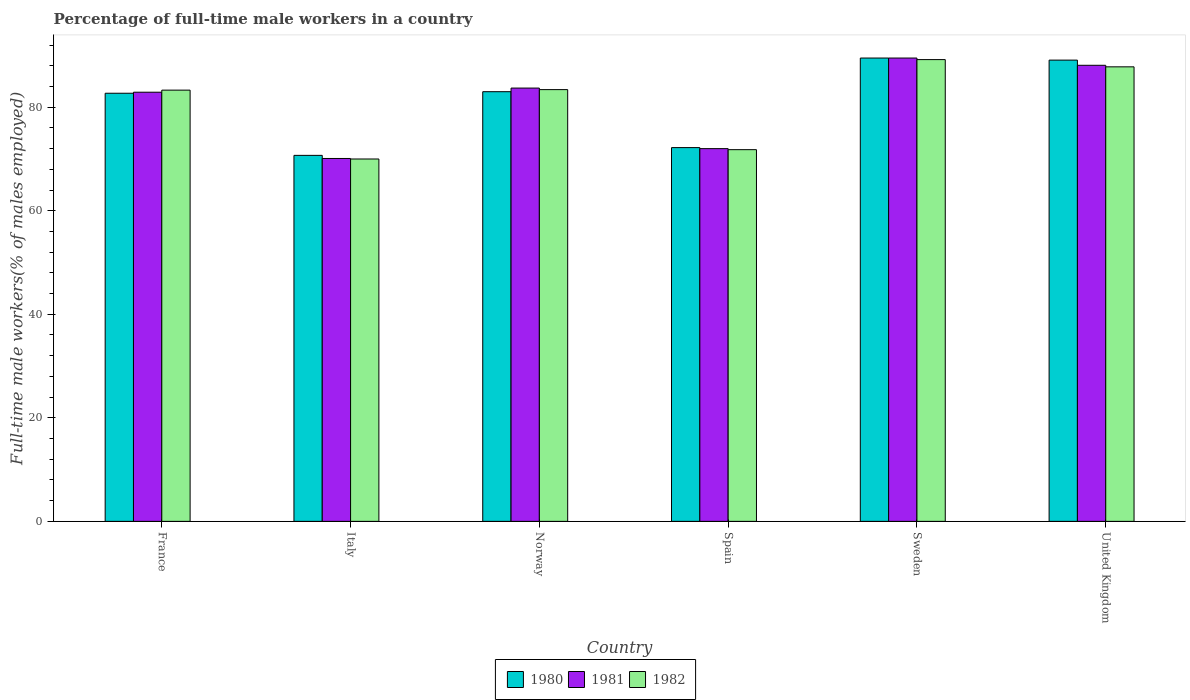How many groups of bars are there?
Ensure brevity in your answer.  6. Are the number of bars on each tick of the X-axis equal?
Offer a very short reply. Yes. How many bars are there on the 5th tick from the left?
Offer a terse response. 3. What is the label of the 2nd group of bars from the left?
Ensure brevity in your answer.  Italy. In how many cases, is the number of bars for a given country not equal to the number of legend labels?
Ensure brevity in your answer.  0. What is the percentage of full-time male workers in 1982 in France?
Offer a very short reply. 83.3. Across all countries, what is the maximum percentage of full-time male workers in 1981?
Ensure brevity in your answer.  89.5. In which country was the percentage of full-time male workers in 1981 minimum?
Your answer should be compact. Italy. What is the total percentage of full-time male workers in 1981 in the graph?
Provide a succinct answer. 486.3. What is the difference between the percentage of full-time male workers in 1982 in Spain and that in Sweden?
Provide a succinct answer. -17.4. What is the difference between the percentage of full-time male workers in 1980 in Spain and the percentage of full-time male workers in 1981 in United Kingdom?
Your response must be concise. -15.9. What is the average percentage of full-time male workers in 1980 per country?
Offer a terse response. 81.2. What is the difference between the percentage of full-time male workers of/in 1981 and percentage of full-time male workers of/in 1982 in Italy?
Offer a very short reply. 0.1. In how many countries, is the percentage of full-time male workers in 1981 greater than 68 %?
Make the answer very short. 6. What is the ratio of the percentage of full-time male workers in 1980 in Italy to that in Norway?
Provide a succinct answer. 0.85. Is the percentage of full-time male workers in 1982 in Italy less than that in Norway?
Keep it short and to the point. Yes. What is the difference between the highest and the second highest percentage of full-time male workers in 1982?
Your response must be concise. 5.8. What is the difference between the highest and the lowest percentage of full-time male workers in 1981?
Provide a succinct answer. 19.4. In how many countries, is the percentage of full-time male workers in 1980 greater than the average percentage of full-time male workers in 1980 taken over all countries?
Offer a very short reply. 4. What does the 3rd bar from the left in France represents?
Your answer should be compact. 1982. Is it the case that in every country, the sum of the percentage of full-time male workers in 1981 and percentage of full-time male workers in 1982 is greater than the percentage of full-time male workers in 1980?
Keep it short and to the point. Yes. Are all the bars in the graph horizontal?
Make the answer very short. No. What is the difference between two consecutive major ticks on the Y-axis?
Provide a short and direct response. 20. Does the graph contain any zero values?
Offer a terse response. No. Does the graph contain grids?
Keep it short and to the point. No. How many legend labels are there?
Your answer should be compact. 3. What is the title of the graph?
Offer a very short reply. Percentage of full-time male workers in a country. What is the label or title of the X-axis?
Ensure brevity in your answer.  Country. What is the label or title of the Y-axis?
Keep it short and to the point. Full-time male workers(% of males employed). What is the Full-time male workers(% of males employed) of 1980 in France?
Give a very brief answer. 82.7. What is the Full-time male workers(% of males employed) of 1981 in France?
Offer a terse response. 82.9. What is the Full-time male workers(% of males employed) of 1982 in France?
Your answer should be very brief. 83.3. What is the Full-time male workers(% of males employed) of 1980 in Italy?
Give a very brief answer. 70.7. What is the Full-time male workers(% of males employed) in 1981 in Italy?
Your answer should be compact. 70.1. What is the Full-time male workers(% of males employed) of 1980 in Norway?
Give a very brief answer. 83. What is the Full-time male workers(% of males employed) in 1981 in Norway?
Your response must be concise. 83.7. What is the Full-time male workers(% of males employed) of 1982 in Norway?
Provide a short and direct response. 83.4. What is the Full-time male workers(% of males employed) of 1980 in Spain?
Offer a terse response. 72.2. What is the Full-time male workers(% of males employed) in 1982 in Spain?
Offer a terse response. 71.8. What is the Full-time male workers(% of males employed) in 1980 in Sweden?
Your answer should be very brief. 89.5. What is the Full-time male workers(% of males employed) of 1981 in Sweden?
Your answer should be compact. 89.5. What is the Full-time male workers(% of males employed) of 1982 in Sweden?
Ensure brevity in your answer.  89.2. What is the Full-time male workers(% of males employed) of 1980 in United Kingdom?
Keep it short and to the point. 89.1. What is the Full-time male workers(% of males employed) in 1981 in United Kingdom?
Ensure brevity in your answer.  88.1. What is the Full-time male workers(% of males employed) of 1982 in United Kingdom?
Provide a short and direct response. 87.8. Across all countries, what is the maximum Full-time male workers(% of males employed) in 1980?
Give a very brief answer. 89.5. Across all countries, what is the maximum Full-time male workers(% of males employed) in 1981?
Give a very brief answer. 89.5. Across all countries, what is the maximum Full-time male workers(% of males employed) of 1982?
Your response must be concise. 89.2. Across all countries, what is the minimum Full-time male workers(% of males employed) of 1980?
Provide a short and direct response. 70.7. Across all countries, what is the minimum Full-time male workers(% of males employed) of 1981?
Your answer should be compact. 70.1. What is the total Full-time male workers(% of males employed) of 1980 in the graph?
Offer a terse response. 487.2. What is the total Full-time male workers(% of males employed) of 1981 in the graph?
Provide a succinct answer. 486.3. What is the total Full-time male workers(% of males employed) in 1982 in the graph?
Give a very brief answer. 485.5. What is the difference between the Full-time male workers(% of males employed) in 1980 in France and that in Italy?
Give a very brief answer. 12. What is the difference between the Full-time male workers(% of males employed) of 1980 in France and that in Norway?
Your response must be concise. -0.3. What is the difference between the Full-time male workers(% of males employed) of 1981 in France and that in Spain?
Your answer should be compact. 10.9. What is the difference between the Full-time male workers(% of males employed) in 1982 in France and that in Spain?
Your answer should be very brief. 11.5. What is the difference between the Full-time male workers(% of males employed) in 1980 in France and that in Sweden?
Your answer should be very brief. -6.8. What is the difference between the Full-time male workers(% of males employed) in 1982 in France and that in United Kingdom?
Your response must be concise. -4.5. What is the difference between the Full-time male workers(% of males employed) in 1980 in Italy and that in Spain?
Your answer should be compact. -1.5. What is the difference between the Full-time male workers(% of males employed) of 1982 in Italy and that in Spain?
Offer a terse response. -1.8. What is the difference between the Full-time male workers(% of males employed) in 1980 in Italy and that in Sweden?
Provide a succinct answer. -18.8. What is the difference between the Full-time male workers(% of males employed) of 1981 in Italy and that in Sweden?
Offer a terse response. -19.4. What is the difference between the Full-time male workers(% of males employed) in 1982 in Italy and that in Sweden?
Your response must be concise. -19.2. What is the difference between the Full-time male workers(% of males employed) in 1980 in Italy and that in United Kingdom?
Provide a short and direct response. -18.4. What is the difference between the Full-time male workers(% of males employed) in 1981 in Italy and that in United Kingdom?
Provide a short and direct response. -18. What is the difference between the Full-time male workers(% of males employed) of 1982 in Italy and that in United Kingdom?
Offer a terse response. -17.8. What is the difference between the Full-time male workers(% of males employed) of 1980 in Norway and that in Spain?
Offer a very short reply. 10.8. What is the difference between the Full-time male workers(% of males employed) in 1981 in Norway and that in Spain?
Provide a succinct answer. 11.7. What is the difference between the Full-time male workers(% of males employed) of 1982 in Norway and that in Spain?
Your answer should be very brief. 11.6. What is the difference between the Full-time male workers(% of males employed) of 1981 in Norway and that in Sweden?
Your answer should be very brief. -5.8. What is the difference between the Full-time male workers(% of males employed) in 1982 in Norway and that in Sweden?
Your response must be concise. -5.8. What is the difference between the Full-time male workers(% of males employed) in 1980 in Norway and that in United Kingdom?
Provide a succinct answer. -6.1. What is the difference between the Full-time male workers(% of males employed) in 1981 in Norway and that in United Kingdom?
Offer a very short reply. -4.4. What is the difference between the Full-time male workers(% of males employed) of 1982 in Norway and that in United Kingdom?
Your answer should be very brief. -4.4. What is the difference between the Full-time male workers(% of males employed) of 1980 in Spain and that in Sweden?
Provide a short and direct response. -17.3. What is the difference between the Full-time male workers(% of males employed) of 1981 in Spain and that in Sweden?
Make the answer very short. -17.5. What is the difference between the Full-time male workers(% of males employed) of 1982 in Spain and that in Sweden?
Offer a terse response. -17.4. What is the difference between the Full-time male workers(% of males employed) in 1980 in Spain and that in United Kingdom?
Ensure brevity in your answer.  -16.9. What is the difference between the Full-time male workers(% of males employed) in 1981 in Spain and that in United Kingdom?
Make the answer very short. -16.1. What is the difference between the Full-time male workers(% of males employed) of 1982 in Sweden and that in United Kingdom?
Provide a succinct answer. 1.4. What is the difference between the Full-time male workers(% of males employed) of 1980 in France and the Full-time male workers(% of males employed) of 1981 in Italy?
Your answer should be very brief. 12.6. What is the difference between the Full-time male workers(% of males employed) in 1981 in France and the Full-time male workers(% of males employed) in 1982 in Italy?
Keep it short and to the point. 12.9. What is the difference between the Full-time male workers(% of males employed) of 1980 in France and the Full-time male workers(% of males employed) of 1981 in Spain?
Your response must be concise. 10.7. What is the difference between the Full-time male workers(% of males employed) in 1981 in France and the Full-time male workers(% of males employed) in 1982 in Spain?
Your response must be concise. 11.1. What is the difference between the Full-time male workers(% of males employed) in 1980 in France and the Full-time male workers(% of males employed) in 1981 in Sweden?
Offer a very short reply. -6.8. What is the difference between the Full-time male workers(% of males employed) in 1980 in France and the Full-time male workers(% of males employed) in 1982 in Sweden?
Your response must be concise. -6.5. What is the difference between the Full-time male workers(% of males employed) of 1981 in France and the Full-time male workers(% of males employed) of 1982 in Sweden?
Make the answer very short. -6.3. What is the difference between the Full-time male workers(% of males employed) in 1980 in France and the Full-time male workers(% of males employed) in 1982 in United Kingdom?
Your response must be concise. -5.1. What is the difference between the Full-time male workers(% of males employed) of 1981 in France and the Full-time male workers(% of males employed) of 1982 in United Kingdom?
Your response must be concise. -4.9. What is the difference between the Full-time male workers(% of males employed) of 1980 in Italy and the Full-time male workers(% of males employed) of 1981 in Norway?
Provide a short and direct response. -13. What is the difference between the Full-time male workers(% of males employed) of 1980 in Italy and the Full-time male workers(% of males employed) of 1982 in Norway?
Your response must be concise. -12.7. What is the difference between the Full-time male workers(% of males employed) in 1981 in Italy and the Full-time male workers(% of males employed) in 1982 in Norway?
Make the answer very short. -13.3. What is the difference between the Full-time male workers(% of males employed) of 1980 in Italy and the Full-time male workers(% of males employed) of 1981 in Spain?
Keep it short and to the point. -1.3. What is the difference between the Full-time male workers(% of males employed) in 1980 in Italy and the Full-time male workers(% of males employed) in 1982 in Spain?
Offer a terse response. -1.1. What is the difference between the Full-time male workers(% of males employed) in 1980 in Italy and the Full-time male workers(% of males employed) in 1981 in Sweden?
Provide a succinct answer. -18.8. What is the difference between the Full-time male workers(% of males employed) of 1980 in Italy and the Full-time male workers(% of males employed) of 1982 in Sweden?
Your response must be concise. -18.5. What is the difference between the Full-time male workers(% of males employed) of 1981 in Italy and the Full-time male workers(% of males employed) of 1982 in Sweden?
Keep it short and to the point. -19.1. What is the difference between the Full-time male workers(% of males employed) of 1980 in Italy and the Full-time male workers(% of males employed) of 1981 in United Kingdom?
Provide a succinct answer. -17.4. What is the difference between the Full-time male workers(% of males employed) of 1980 in Italy and the Full-time male workers(% of males employed) of 1982 in United Kingdom?
Give a very brief answer. -17.1. What is the difference between the Full-time male workers(% of males employed) in 1981 in Italy and the Full-time male workers(% of males employed) in 1982 in United Kingdom?
Ensure brevity in your answer.  -17.7. What is the difference between the Full-time male workers(% of males employed) in 1980 in Norway and the Full-time male workers(% of males employed) in 1982 in Spain?
Give a very brief answer. 11.2. What is the difference between the Full-time male workers(% of males employed) of 1981 in Norway and the Full-time male workers(% of males employed) of 1982 in Spain?
Give a very brief answer. 11.9. What is the difference between the Full-time male workers(% of males employed) in 1980 in Norway and the Full-time male workers(% of males employed) in 1982 in Sweden?
Ensure brevity in your answer.  -6.2. What is the difference between the Full-time male workers(% of males employed) in 1980 in Norway and the Full-time male workers(% of males employed) in 1982 in United Kingdom?
Provide a succinct answer. -4.8. What is the difference between the Full-time male workers(% of males employed) in 1980 in Spain and the Full-time male workers(% of males employed) in 1981 in Sweden?
Give a very brief answer. -17.3. What is the difference between the Full-time male workers(% of males employed) of 1980 in Spain and the Full-time male workers(% of males employed) of 1982 in Sweden?
Provide a short and direct response. -17. What is the difference between the Full-time male workers(% of males employed) in 1981 in Spain and the Full-time male workers(% of males employed) in 1982 in Sweden?
Your answer should be compact. -17.2. What is the difference between the Full-time male workers(% of males employed) of 1980 in Spain and the Full-time male workers(% of males employed) of 1981 in United Kingdom?
Your answer should be compact. -15.9. What is the difference between the Full-time male workers(% of males employed) in 1980 in Spain and the Full-time male workers(% of males employed) in 1982 in United Kingdom?
Your answer should be very brief. -15.6. What is the difference between the Full-time male workers(% of males employed) of 1981 in Spain and the Full-time male workers(% of males employed) of 1982 in United Kingdom?
Make the answer very short. -15.8. What is the difference between the Full-time male workers(% of males employed) in 1980 in Sweden and the Full-time male workers(% of males employed) in 1981 in United Kingdom?
Offer a very short reply. 1.4. What is the difference between the Full-time male workers(% of males employed) in 1980 in Sweden and the Full-time male workers(% of males employed) in 1982 in United Kingdom?
Provide a short and direct response. 1.7. What is the average Full-time male workers(% of males employed) in 1980 per country?
Offer a very short reply. 81.2. What is the average Full-time male workers(% of males employed) of 1981 per country?
Your answer should be very brief. 81.05. What is the average Full-time male workers(% of males employed) of 1982 per country?
Offer a terse response. 80.92. What is the difference between the Full-time male workers(% of males employed) of 1980 and Full-time male workers(% of males employed) of 1981 in France?
Make the answer very short. -0.2. What is the difference between the Full-time male workers(% of males employed) in 1980 and Full-time male workers(% of males employed) in 1982 in France?
Make the answer very short. -0.6. What is the difference between the Full-time male workers(% of males employed) in 1981 and Full-time male workers(% of males employed) in 1982 in France?
Provide a succinct answer. -0.4. What is the difference between the Full-time male workers(% of males employed) of 1980 and Full-time male workers(% of males employed) of 1981 in Italy?
Give a very brief answer. 0.6. What is the difference between the Full-time male workers(% of males employed) in 1980 and Full-time male workers(% of males employed) in 1981 in Norway?
Ensure brevity in your answer.  -0.7. What is the difference between the Full-time male workers(% of males employed) of 1980 and Full-time male workers(% of males employed) of 1982 in Norway?
Provide a succinct answer. -0.4. What is the difference between the Full-time male workers(% of males employed) in 1981 and Full-time male workers(% of males employed) in 1982 in Spain?
Your answer should be very brief. 0.2. What is the difference between the Full-time male workers(% of males employed) of 1980 and Full-time male workers(% of males employed) of 1981 in Sweden?
Offer a terse response. 0. What is the difference between the Full-time male workers(% of males employed) in 1980 and Full-time male workers(% of males employed) in 1982 in Sweden?
Your answer should be compact. 0.3. What is the difference between the Full-time male workers(% of males employed) of 1980 and Full-time male workers(% of males employed) of 1981 in United Kingdom?
Offer a terse response. 1. What is the difference between the Full-time male workers(% of males employed) in 1981 and Full-time male workers(% of males employed) in 1982 in United Kingdom?
Ensure brevity in your answer.  0.3. What is the ratio of the Full-time male workers(% of males employed) in 1980 in France to that in Italy?
Your response must be concise. 1.17. What is the ratio of the Full-time male workers(% of males employed) in 1981 in France to that in Italy?
Give a very brief answer. 1.18. What is the ratio of the Full-time male workers(% of males employed) in 1982 in France to that in Italy?
Provide a succinct answer. 1.19. What is the ratio of the Full-time male workers(% of males employed) of 1980 in France to that in Norway?
Offer a terse response. 1. What is the ratio of the Full-time male workers(% of males employed) of 1981 in France to that in Norway?
Give a very brief answer. 0.99. What is the ratio of the Full-time male workers(% of males employed) in 1980 in France to that in Spain?
Make the answer very short. 1.15. What is the ratio of the Full-time male workers(% of males employed) of 1981 in France to that in Spain?
Offer a terse response. 1.15. What is the ratio of the Full-time male workers(% of males employed) in 1982 in France to that in Spain?
Your answer should be very brief. 1.16. What is the ratio of the Full-time male workers(% of males employed) in 1980 in France to that in Sweden?
Offer a terse response. 0.92. What is the ratio of the Full-time male workers(% of males employed) in 1981 in France to that in Sweden?
Your response must be concise. 0.93. What is the ratio of the Full-time male workers(% of males employed) in 1982 in France to that in Sweden?
Provide a short and direct response. 0.93. What is the ratio of the Full-time male workers(% of males employed) of 1980 in France to that in United Kingdom?
Offer a terse response. 0.93. What is the ratio of the Full-time male workers(% of males employed) in 1981 in France to that in United Kingdom?
Your response must be concise. 0.94. What is the ratio of the Full-time male workers(% of males employed) of 1982 in France to that in United Kingdom?
Your answer should be very brief. 0.95. What is the ratio of the Full-time male workers(% of males employed) of 1980 in Italy to that in Norway?
Your answer should be compact. 0.85. What is the ratio of the Full-time male workers(% of males employed) of 1981 in Italy to that in Norway?
Ensure brevity in your answer.  0.84. What is the ratio of the Full-time male workers(% of males employed) in 1982 in Italy to that in Norway?
Provide a succinct answer. 0.84. What is the ratio of the Full-time male workers(% of males employed) in 1980 in Italy to that in Spain?
Your answer should be very brief. 0.98. What is the ratio of the Full-time male workers(% of males employed) in 1981 in Italy to that in Spain?
Your answer should be very brief. 0.97. What is the ratio of the Full-time male workers(% of males employed) of 1982 in Italy to that in Spain?
Provide a succinct answer. 0.97. What is the ratio of the Full-time male workers(% of males employed) of 1980 in Italy to that in Sweden?
Ensure brevity in your answer.  0.79. What is the ratio of the Full-time male workers(% of males employed) in 1981 in Italy to that in Sweden?
Provide a succinct answer. 0.78. What is the ratio of the Full-time male workers(% of males employed) in 1982 in Italy to that in Sweden?
Make the answer very short. 0.78. What is the ratio of the Full-time male workers(% of males employed) of 1980 in Italy to that in United Kingdom?
Your answer should be compact. 0.79. What is the ratio of the Full-time male workers(% of males employed) in 1981 in Italy to that in United Kingdom?
Offer a very short reply. 0.8. What is the ratio of the Full-time male workers(% of males employed) of 1982 in Italy to that in United Kingdom?
Provide a short and direct response. 0.8. What is the ratio of the Full-time male workers(% of males employed) in 1980 in Norway to that in Spain?
Offer a very short reply. 1.15. What is the ratio of the Full-time male workers(% of males employed) in 1981 in Norway to that in Spain?
Ensure brevity in your answer.  1.16. What is the ratio of the Full-time male workers(% of males employed) in 1982 in Norway to that in Spain?
Ensure brevity in your answer.  1.16. What is the ratio of the Full-time male workers(% of males employed) of 1980 in Norway to that in Sweden?
Make the answer very short. 0.93. What is the ratio of the Full-time male workers(% of males employed) in 1981 in Norway to that in Sweden?
Ensure brevity in your answer.  0.94. What is the ratio of the Full-time male workers(% of males employed) in 1982 in Norway to that in Sweden?
Offer a terse response. 0.94. What is the ratio of the Full-time male workers(% of males employed) in 1980 in Norway to that in United Kingdom?
Offer a terse response. 0.93. What is the ratio of the Full-time male workers(% of males employed) of 1981 in Norway to that in United Kingdom?
Offer a terse response. 0.95. What is the ratio of the Full-time male workers(% of males employed) of 1982 in Norway to that in United Kingdom?
Give a very brief answer. 0.95. What is the ratio of the Full-time male workers(% of males employed) in 1980 in Spain to that in Sweden?
Keep it short and to the point. 0.81. What is the ratio of the Full-time male workers(% of males employed) of 1981 in Spain to that in Sweden?
Offer a very short reply. 0.8. What is the ratio of the Full-time male workers(% of males employed) of 1982 in Spain to that in Sweden?
Provide a succinct answer. 0.8. What is the ratio of the Full-time male workers(% of males employed) in 1980 in Spain to that in United Kingdom?
Your response must be concise. 0.81. What is the ratio of the Full-time male workers(% of males employed) in 1981 in Spain to that in United Kingdom?
Offer a very short reply. 0.82. What is the ratio of the Full-time male workers(% of males employed) in 1982 in Spain to that in United Kingdom?
Your answer should be compact. 0.82. What is the ratio of the Full-time male workers(% of males employed) in 1980 in Sweden to that in United Kingdom?
Give a very brief answer. 1. What is the ratio of the Full-time male workers(% of males employed) in 1981 in Sweden to that in United Kingdom?
Your answer should be compact. 1.02. What is the ratio of the Full-time male workers(% of males employed) of 1982 in Sweden to that in United Kingdom?
Give a very brief answer. 1.02. What is the difference between the highest and the second highest Full-time male workers(% of males employed) of 1980?
Make the answer very short. 0.4. What is the difference between the highest and the second highest Full-time male workers(% of males employed) of 1981?
Provide a short and direct response. 1.4. What is the difference between the highest and the second highest Full-time male workers(% of males employed) in 1982?
Ensure brevity in your answer.  1.4. What is the difference between the highest and the lowest Full-time male workers(% of males employed) in 1981?
Offer a very short reply. 19.4. 